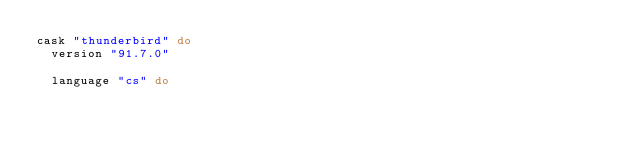<code> <loc_0><loc_0><loc_500><loc_500><_Ruby_>cask "thunderbird" do
  version "91.7.0"

  language "cs" do</code> 